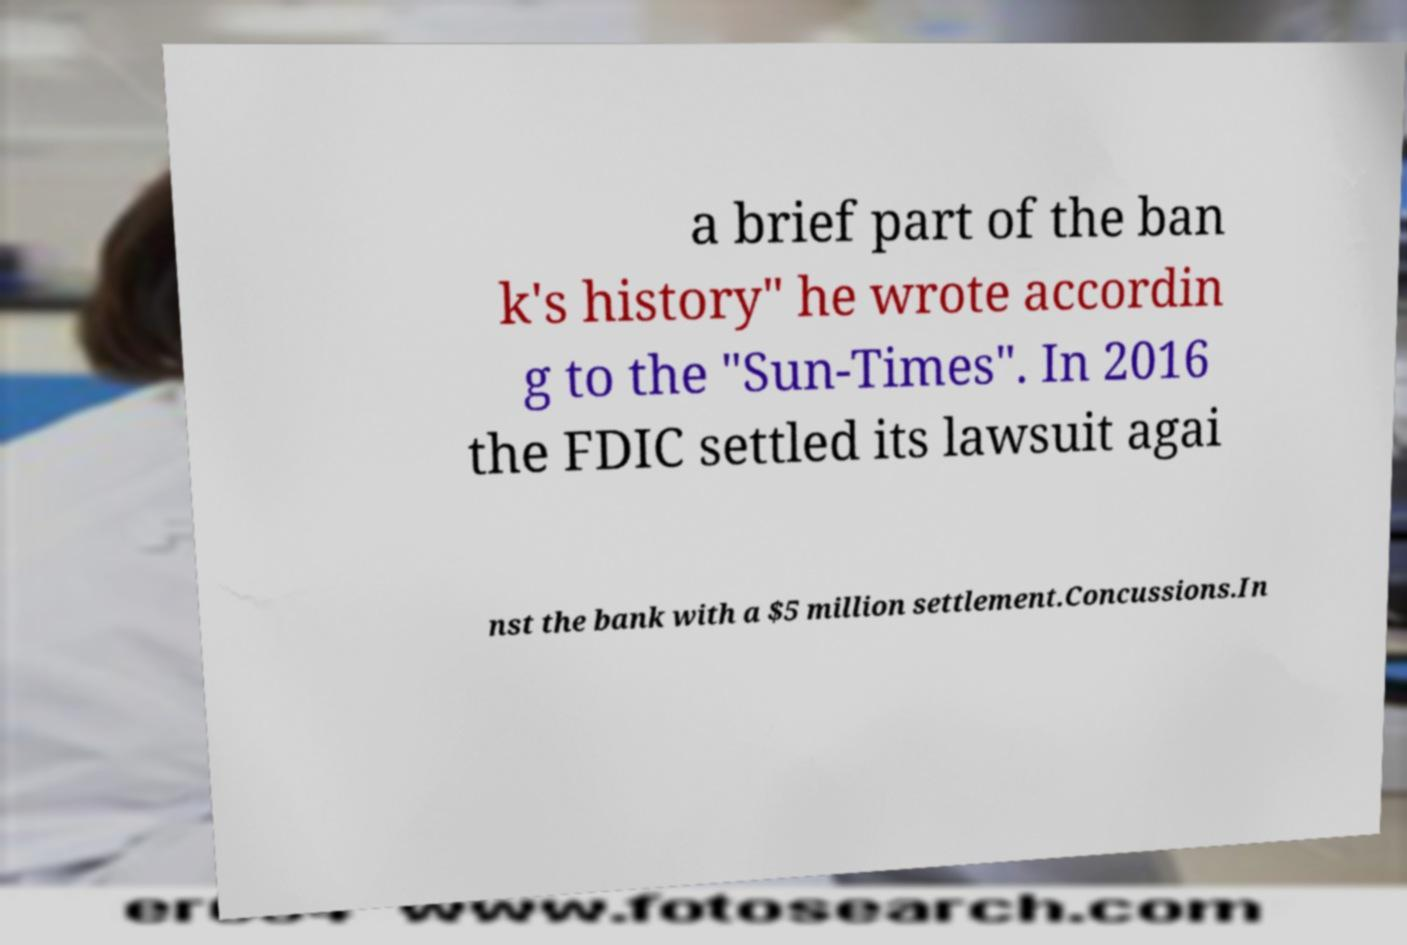There's text embedded in this image that I need extracted. Can you transcribe it verbatim? a brief part of the ban k's history" he wrote accordin g to the "Sun-Times". In 2016 the FDIC settled its lawsuit agai nst the bank with a $5 million settlement.Concussions.In 